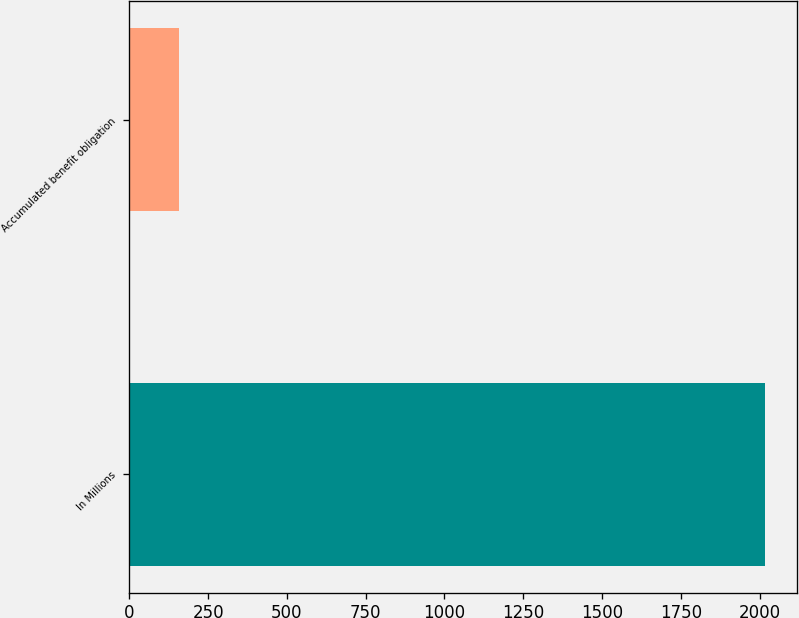Convert chart to OTSL. <chart><loc_0><loc_0><loc_500><loc_500><bar_chart><fcel>In Millions<fcel>Accumulated benefit obligation<nl><fcel>2016<fcel>159.3<nl></chart> 